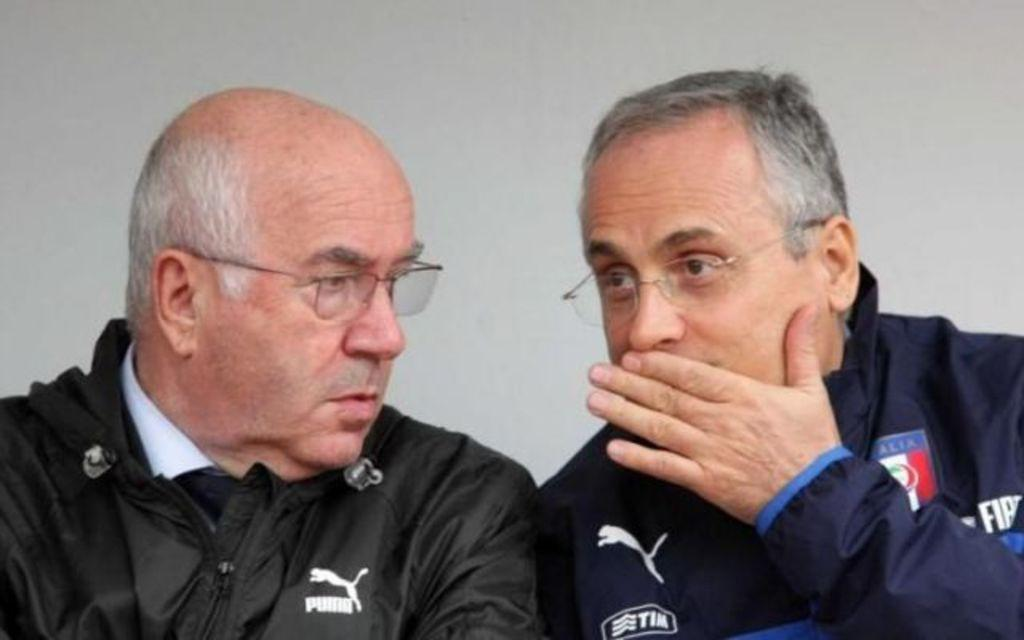How many people are in the image? There are two persons in the image. What are the persons wearing that is visible in the image? Both persons are wearing spectacles. What can be seen in the background of the image? There is a wall in the background of the image. What type of sweater is the person on the right wearing in the image? There is no mention of a sweater in the image. 